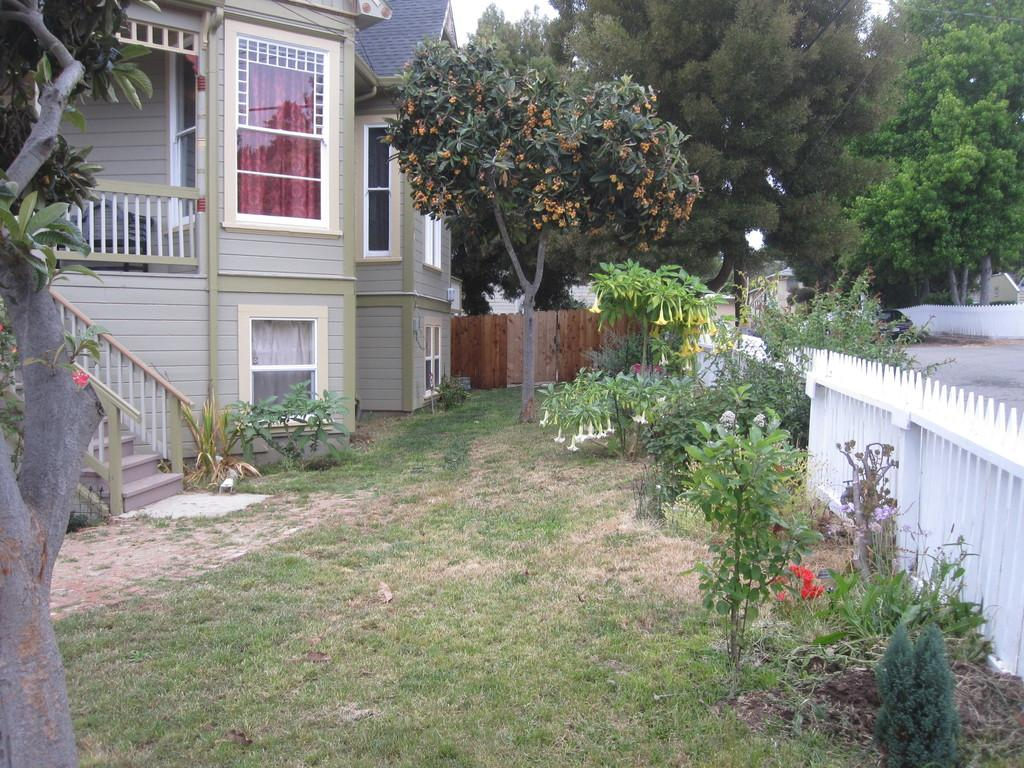What type of structures can be seen in the image? There are houses in the image. What type of fencing is present in the image? There is wooden fencing in the image. What type of vegetation is visible in the image? There is grass visible in the image. What can be seen in the background of the image? There are trees and a road in the background of the image. How many crates of apples can be seen in the image? There are no crates of apples present in the image. Are there any giants visible in the image? There are no giants present in the image. 